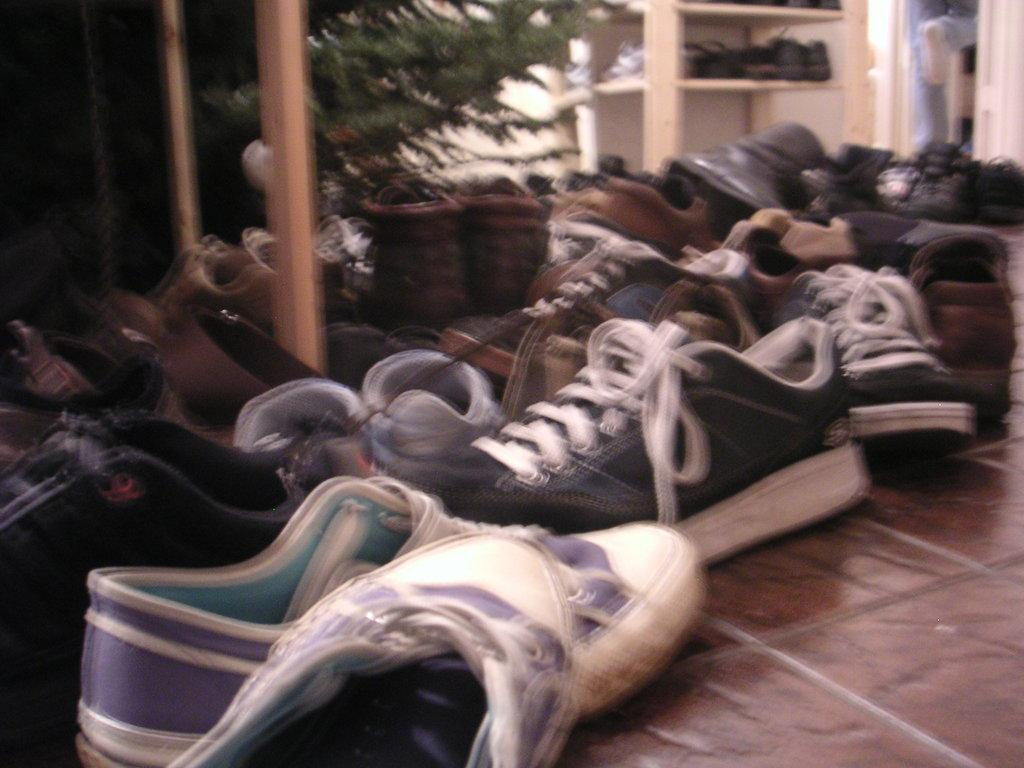What type of objects can be seen in large quantities in the image? There are many pairs of shoes in the image. Can you identify any other objects or living organisms in the image? Yes, there is a plant in the image. What type of cow can be seen grazing near the plant in the image? There is no cow present in the image; it only features shoes and a plant. 